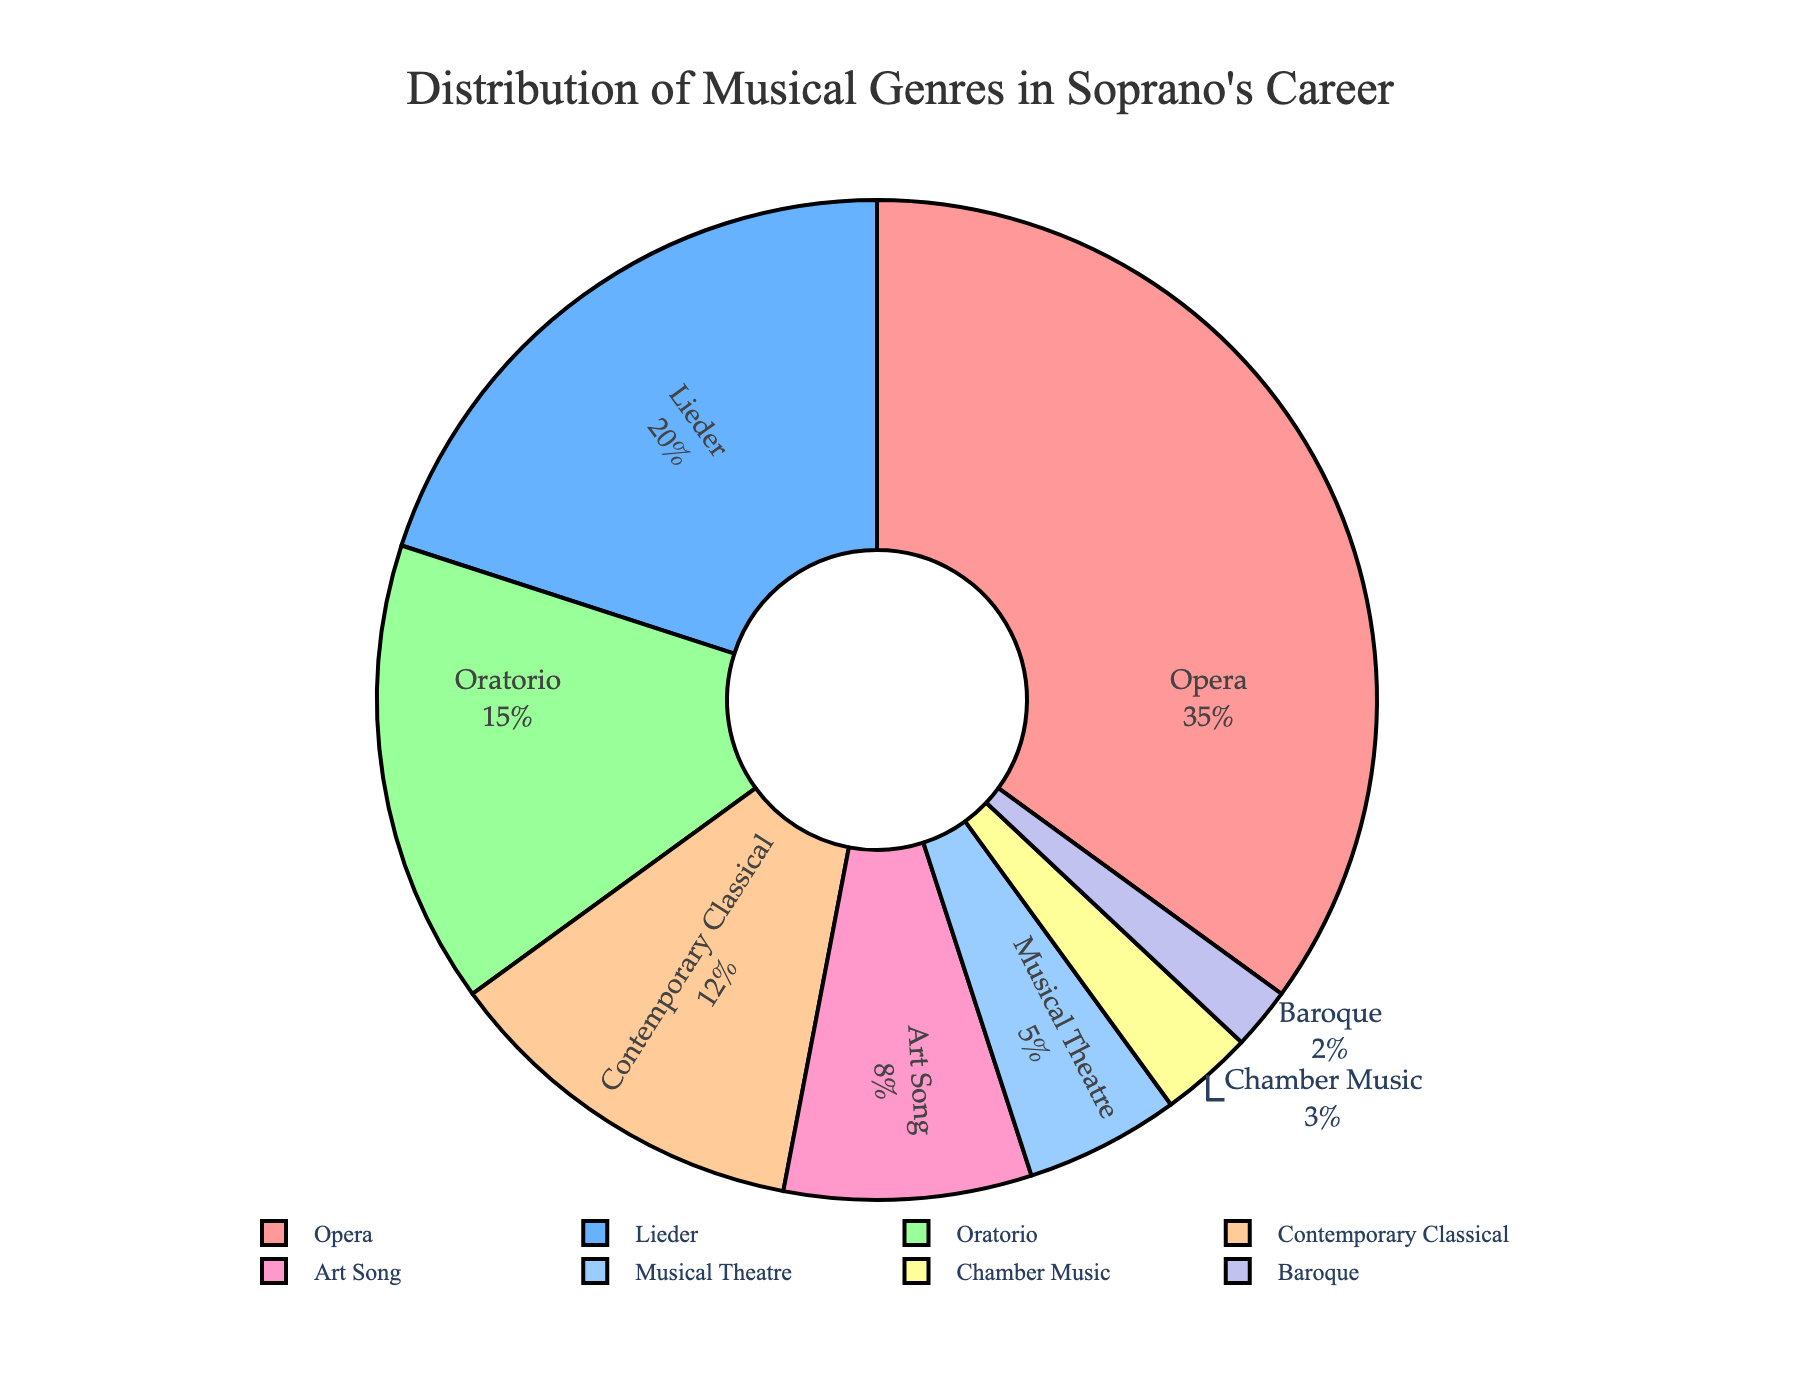What percentage of the soprano's performances are comprised of Opera and Oratorio combined? To find the combined percentage of Opera and Oratorio, add their individual percentages. Opera is 35% and Oratorio is 15%, so 35 + 15 = 50%.
Answer: 50% Which genre has the lowest percentage of performances? The genre with the smallest percentage of performances can be identified by looking at the smallest segment in the pie chart. Baroque has the lowest percentage at 2%.
Answer: Baroque How does the percentage of Contemporary Classical performances compare to Art Song performances? Contemporary Classical is 12% and Art Song is 8%. Comparing the two, Contemporary Classical has a higher percentage of performances than Art Song.
Answer: Contemporary Classical is higher What is the total percentage of performances for genres that are less than 10% each? The genres with less than 10% are Art Song (8%), Musical Theatre (5%), Chamber Music (3%), and Baroque (2%). Adding these together gives 8 + 5 + 3 + 2 = 18%.
Answer: 18% Which genre has the second-highest percentage of performances? The genre with the second-highest percentage can be found by looking at the segment just below the largest one. Lieder has the second-highest percentage at 20%.
Answer: Lieder If you combined the percentages of Lieder and Chamber Music, would it be greater than that of Opera? Lieder is 20% and Chamber Music is 3%, so combined they are 20 + 3 = 23%, which is less than Opera's 35%.
Answer: No Identify the genre represented by the color that is second from the left in the legend. The legend organizes the slices from left to right according to their order in the data. The second color is light blue which corresponds to Lieder.
Answer: Lieder How much more percentage of performances does Musical Theatre have compared to Baroque? Musical Theatre has 5% while Baroque has 2%. The difference between the two is 5 - 2 = 3%.
Answer: 3% What is the average percentage of the three most performed genres? The three most performed genres are Opera (35%), Lieder (20%), and Oratorio (15%). To find the average: (35 + 20 + 15) / 3 = 70 / 3 = 23.33%.
Answer: 23.33% If you took the sum of the percentages of the top four genres, what would it be? The top four genres are Opera (35%), Lieder (20%), Oratorio (15%), and Contemporary Classical (12%). Adding these together gives 35 + 20 + 15 + 12 = 82%.
Answer: 82% 